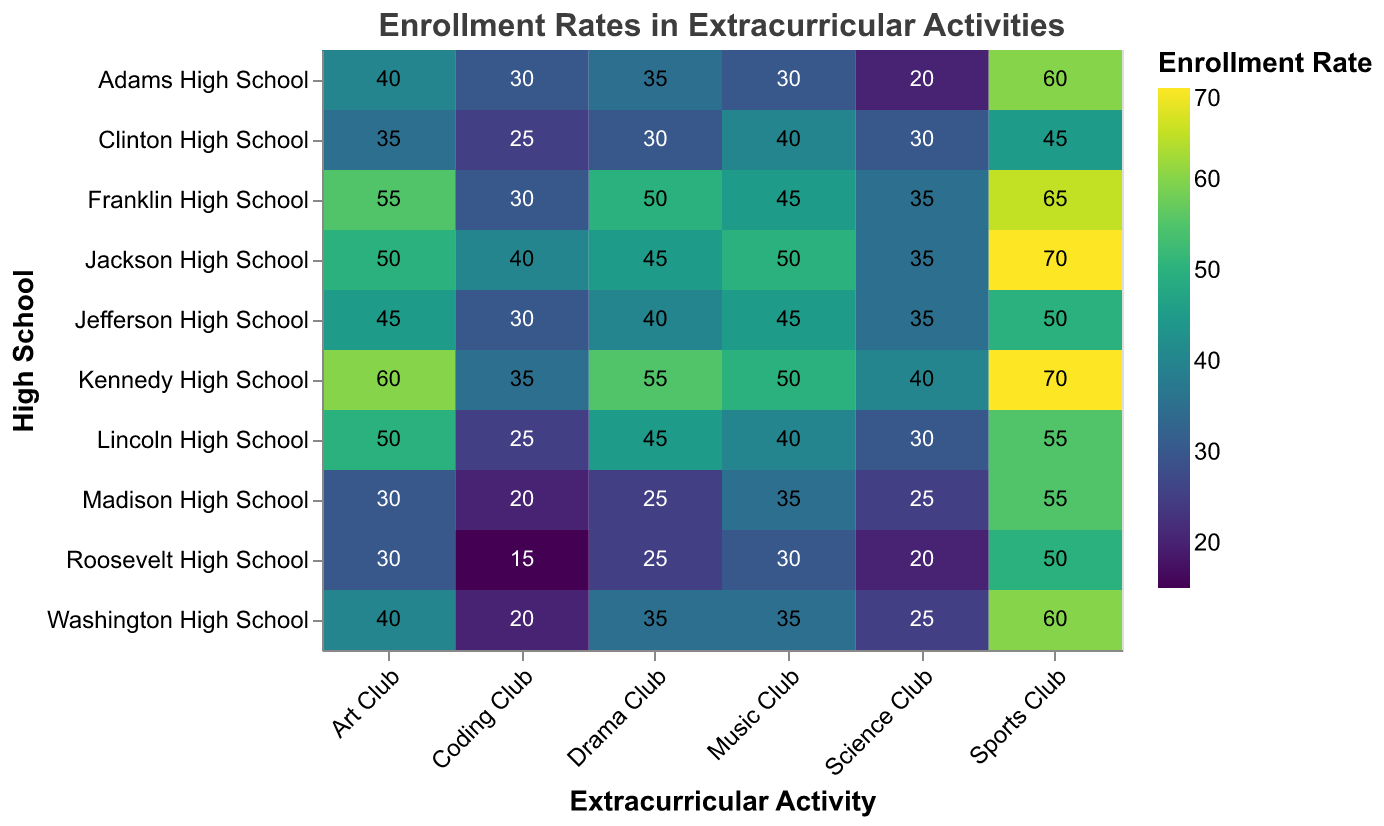Which high school has the highest enrollment in the Coding Club? To determine the school with the highest enrollment in the Coding Club, look at the "Coding Club" column on the heatmap and find the cell with the darkest color or largest value.
Answer: Jackson High School What is the enrollment rate for the Science Club at Roosevelt High School? Find Roosevelt High School on the Y-axis and locate the cell corresponding to the Science Club column. Read the value from the heatmap.
Answer: 20 Which extracurricular activity has the highest average enrollment rate across all high schools? Calculate the average enrollment rate for each extracurricular activity by summing the values for each school and dividing by the number of schools, then compare these averages to find the highest one. Sports Club has the highest average.
Answer: Sports Club Compare the enrollment in the Art Club between Lincoln High School and Adams High School. Which school has higher participation? Locate Lincoln High School and Adams High School on the Y-axis and compare the values in the Art Club column. Lincoln High School has an enrollment of 50, and Adams High School has an enrollment of 40.
Answer: Lincoln High School What is the total enrollment for the Drama Club across all high schools? Sum the Drama Club column values from each school: 45 + 35 + 40 + 25 + 55 + 30 + 50 + 25 + 35 + 45 = 385.
Answer: 385 Which school has the least enrollment in the Music Club? Look for the school with the lightest color or lowest value in the Music Club column on the heatmap.
Answer: Roosevelt High School Is the enrollment in the Sports Club higher at Kennedy High School or Franklin High School? Compare the values for Sports Club at Kennedy High School and Franklin High School. Kennedy has 70, while Franklin has 65.
Answer: Kennedy High School Across all activities, which school consistently has high enrollment rates? Evaluate the heatmap visually to see which school's cells consistently have darker shades indicating higher values. Kennedy High School shows consistently high enrollments across all activities.
Answer: Kennedy High School How does the enrollment in the Coding Club at Madison High School compare to the enrollment in the Science Club at the same school? Locate Madison High School and compare the values in the Coding Club and Science Club columns. Both the Coding Club and Science Club have an enrollment rate of 20.
Answer: Equal What is the combined enrollment for all activities at Clinton High School? Sum the values across all columns for Clinton High School: 35 + 30 + 25 + 30 + 45 + 40 = 205.
Answer: 205 